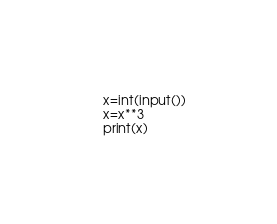Convert code to text. <code><loc_0><loc_0><loc_500><loc_500><_Python_>x=int(input())
x=x**3
print(x)
</code> 